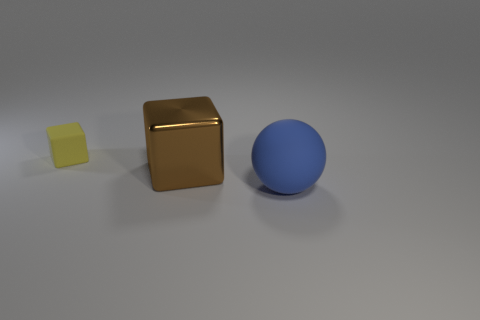Add 1 tiny gray rubber blocks. How many objects exist? 4 Subtract 1 blocks. How many blocks are left? 1 Subtract all balls. How many objects are left? 2 Subtract all blue cylinders. How many brown cubes are left? 1 Subtract all blue rubber blocks. Subtract all big spheres. How many objects are left? 2 Add 1 small matte blocks. How many small matte blocks are left? 2 Add 1 large blue rubber objects. How many large blue rubber objects exist? 2 Subtract 0 gray cubes. How many objects are left? 3 Subtract all purple blocks. Subtract all brown balls. How many blocks are left? 2 